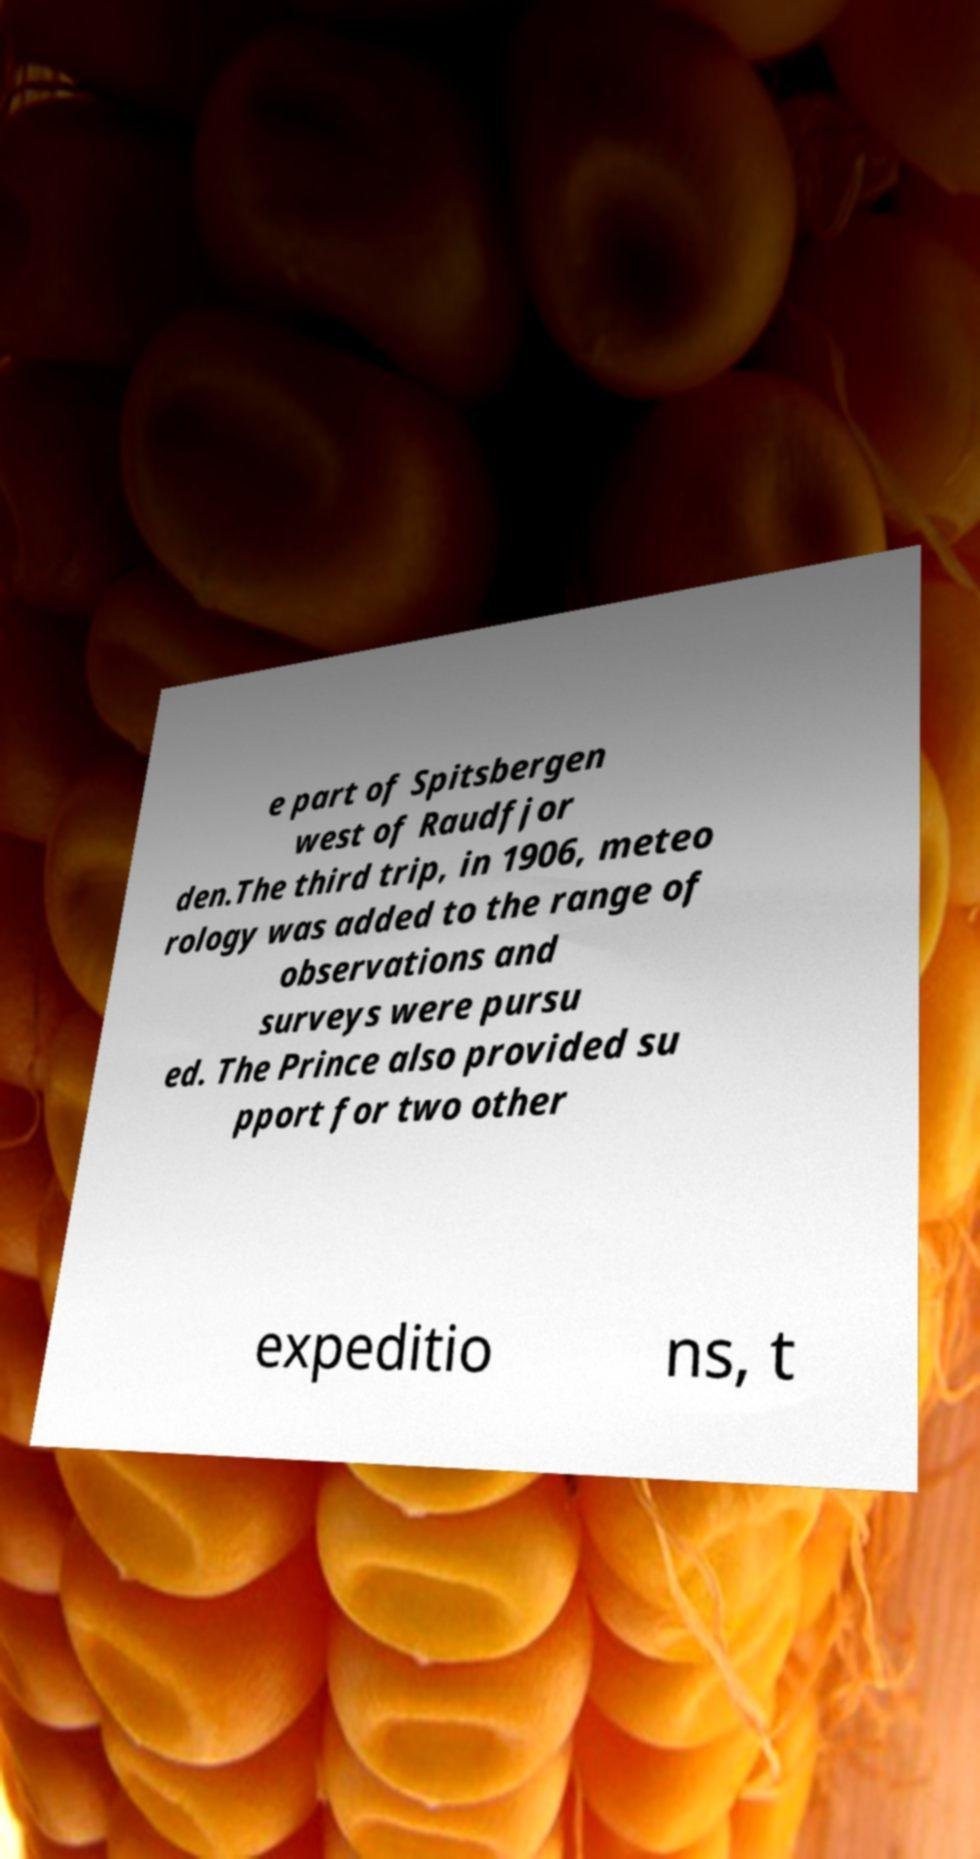Could you extract and type out the text from this image? e part of Spitsbergen west of Raudfjor den.The third trip, in 1906, meteo rology was added to the range of observations and surveys were pursu ed. The Prince also provided su pport for two other expeditio ns, t 